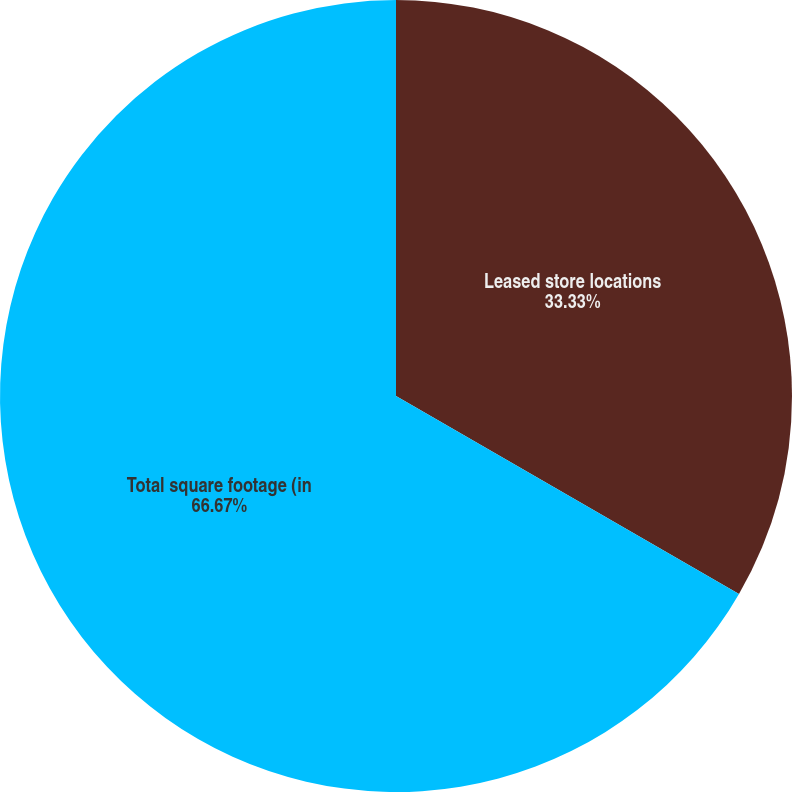Convert chart to OTSL. <chart><loc_0><loc_0><loc_500><loc_500><pie_chart><fcel>Leased store locations<fcel>Total square footage (in<nl><fcel>33.33%<fcel>66.67%<nl></chart> 